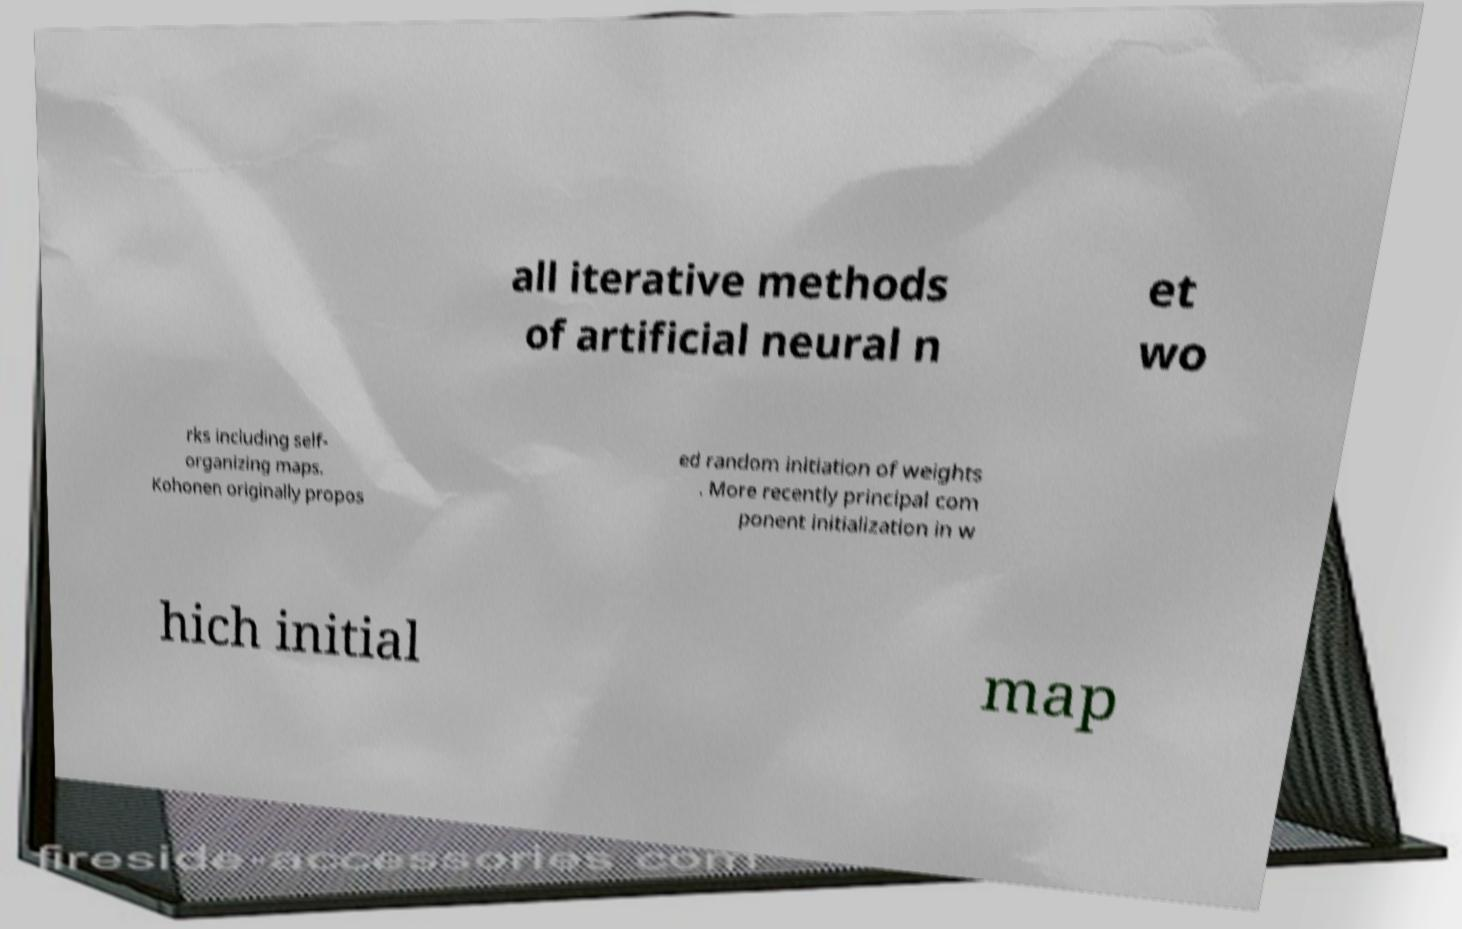Could you assist in decoding the text presented in this image and type it out clearly? all iterative methods of artificial neural n et wo rks including self- organizing maps. Kohonen originally propos ed random initiation of weights . More recently principal com ponent initialization in w hich initial map 